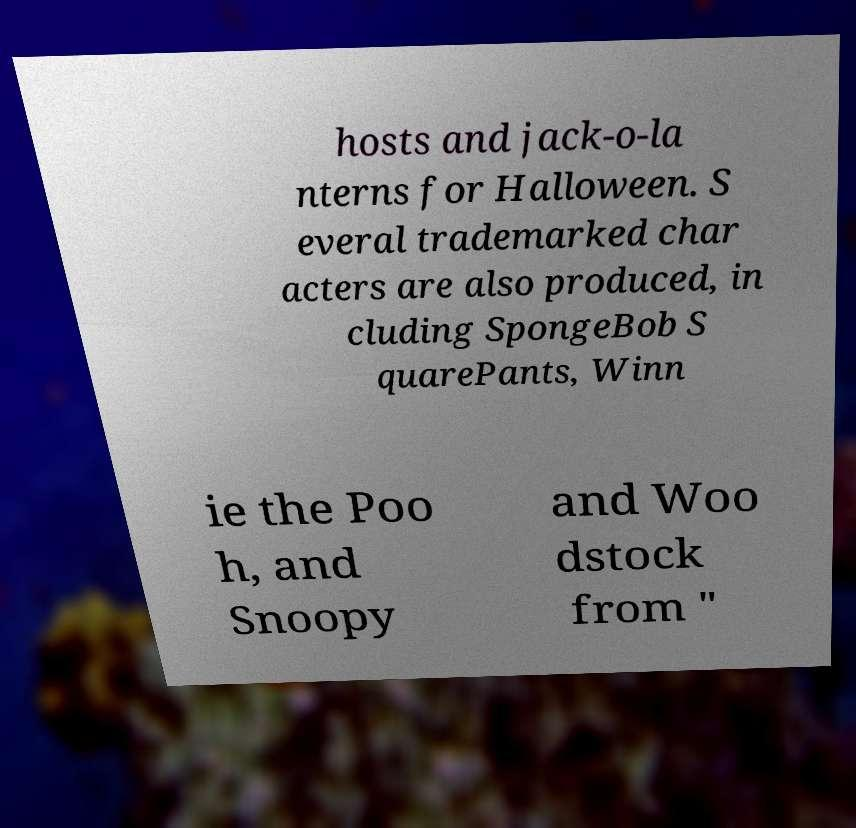I need the written content from this picture converted into text. Can you do that? hosts and jack-o-la nterns for Halloween. S everal trademarked char acters are also produced, in cluding SpongeBob S quarePants, Winn ie the Poo h, and Snoopy and Woo dstock from " 